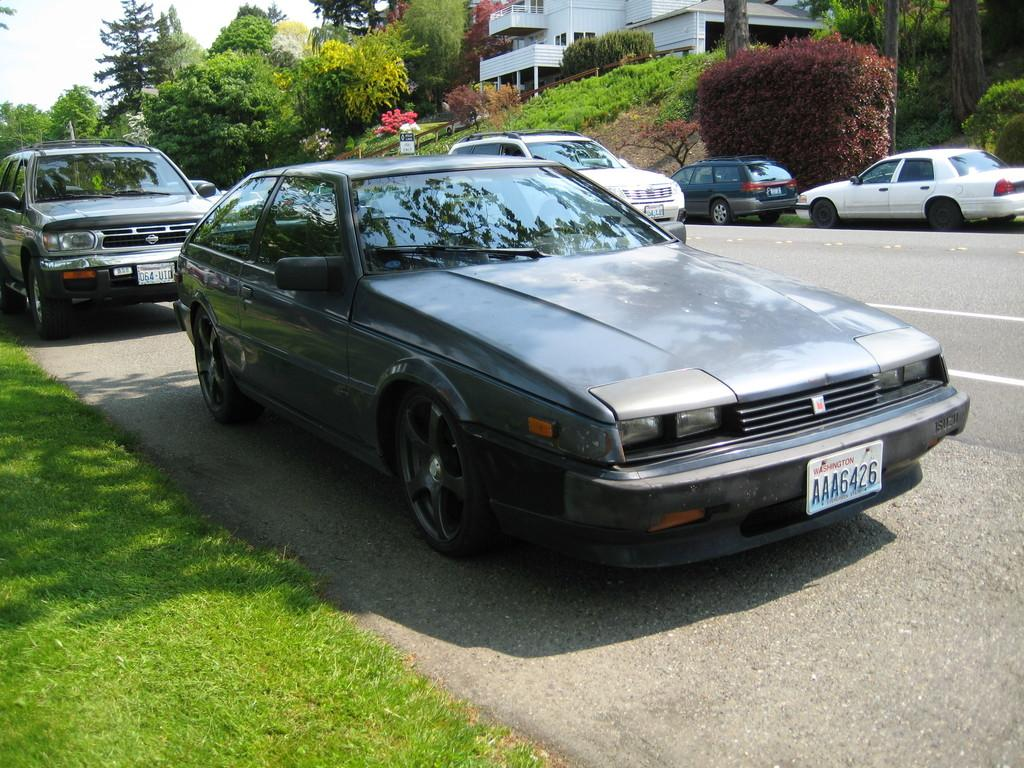What type of vehicles can be seen in the image? There are cars in the image. What natural elements are present in the image? There are trees, plants, grass, and sky visible in the image. What type of structure is in the image? There is a building in the image. What is the surface on which the cars are traveling? There is a road in the image. What type of crate is being used by the secretary in the image? There is no crate or secretary present in the image. What is the rate of the cars' speed in the image? The image does not provide information about the speed of the cars, so it cannot be determined. 